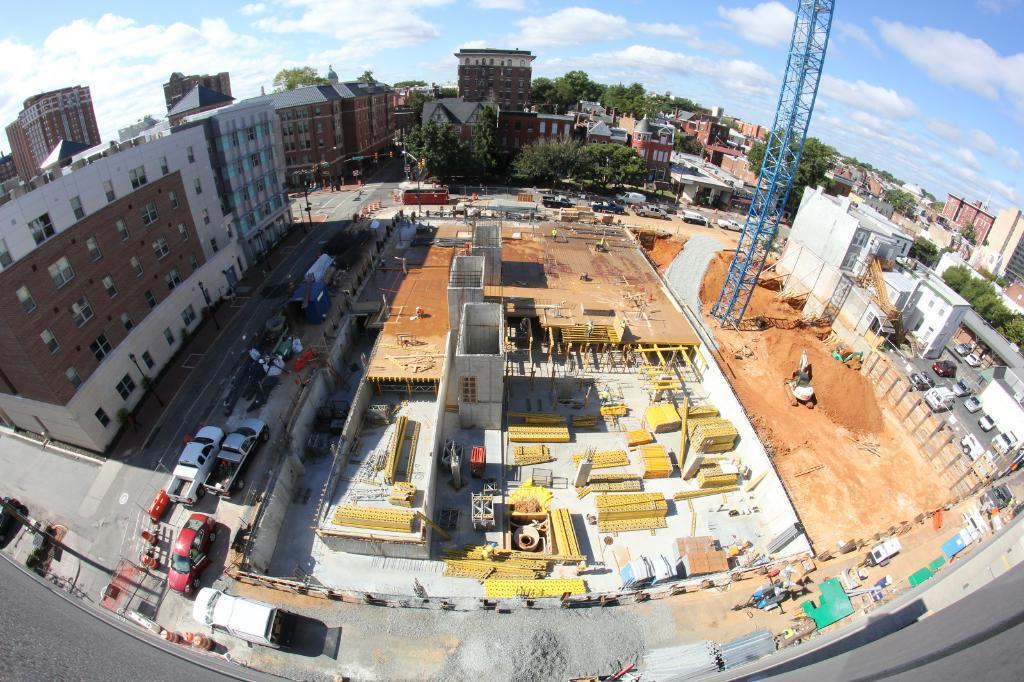Describe this image in one or two sentences. In this image I can see few buildings, windows, trees, poles, trees, mud and few vehicles on the road. I can see the construction site and few objects on the road. 